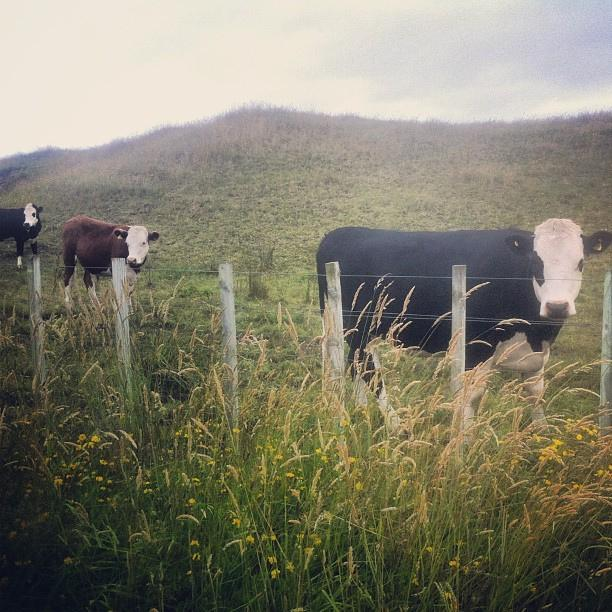What color is the cow in between the two milkcows? brown 